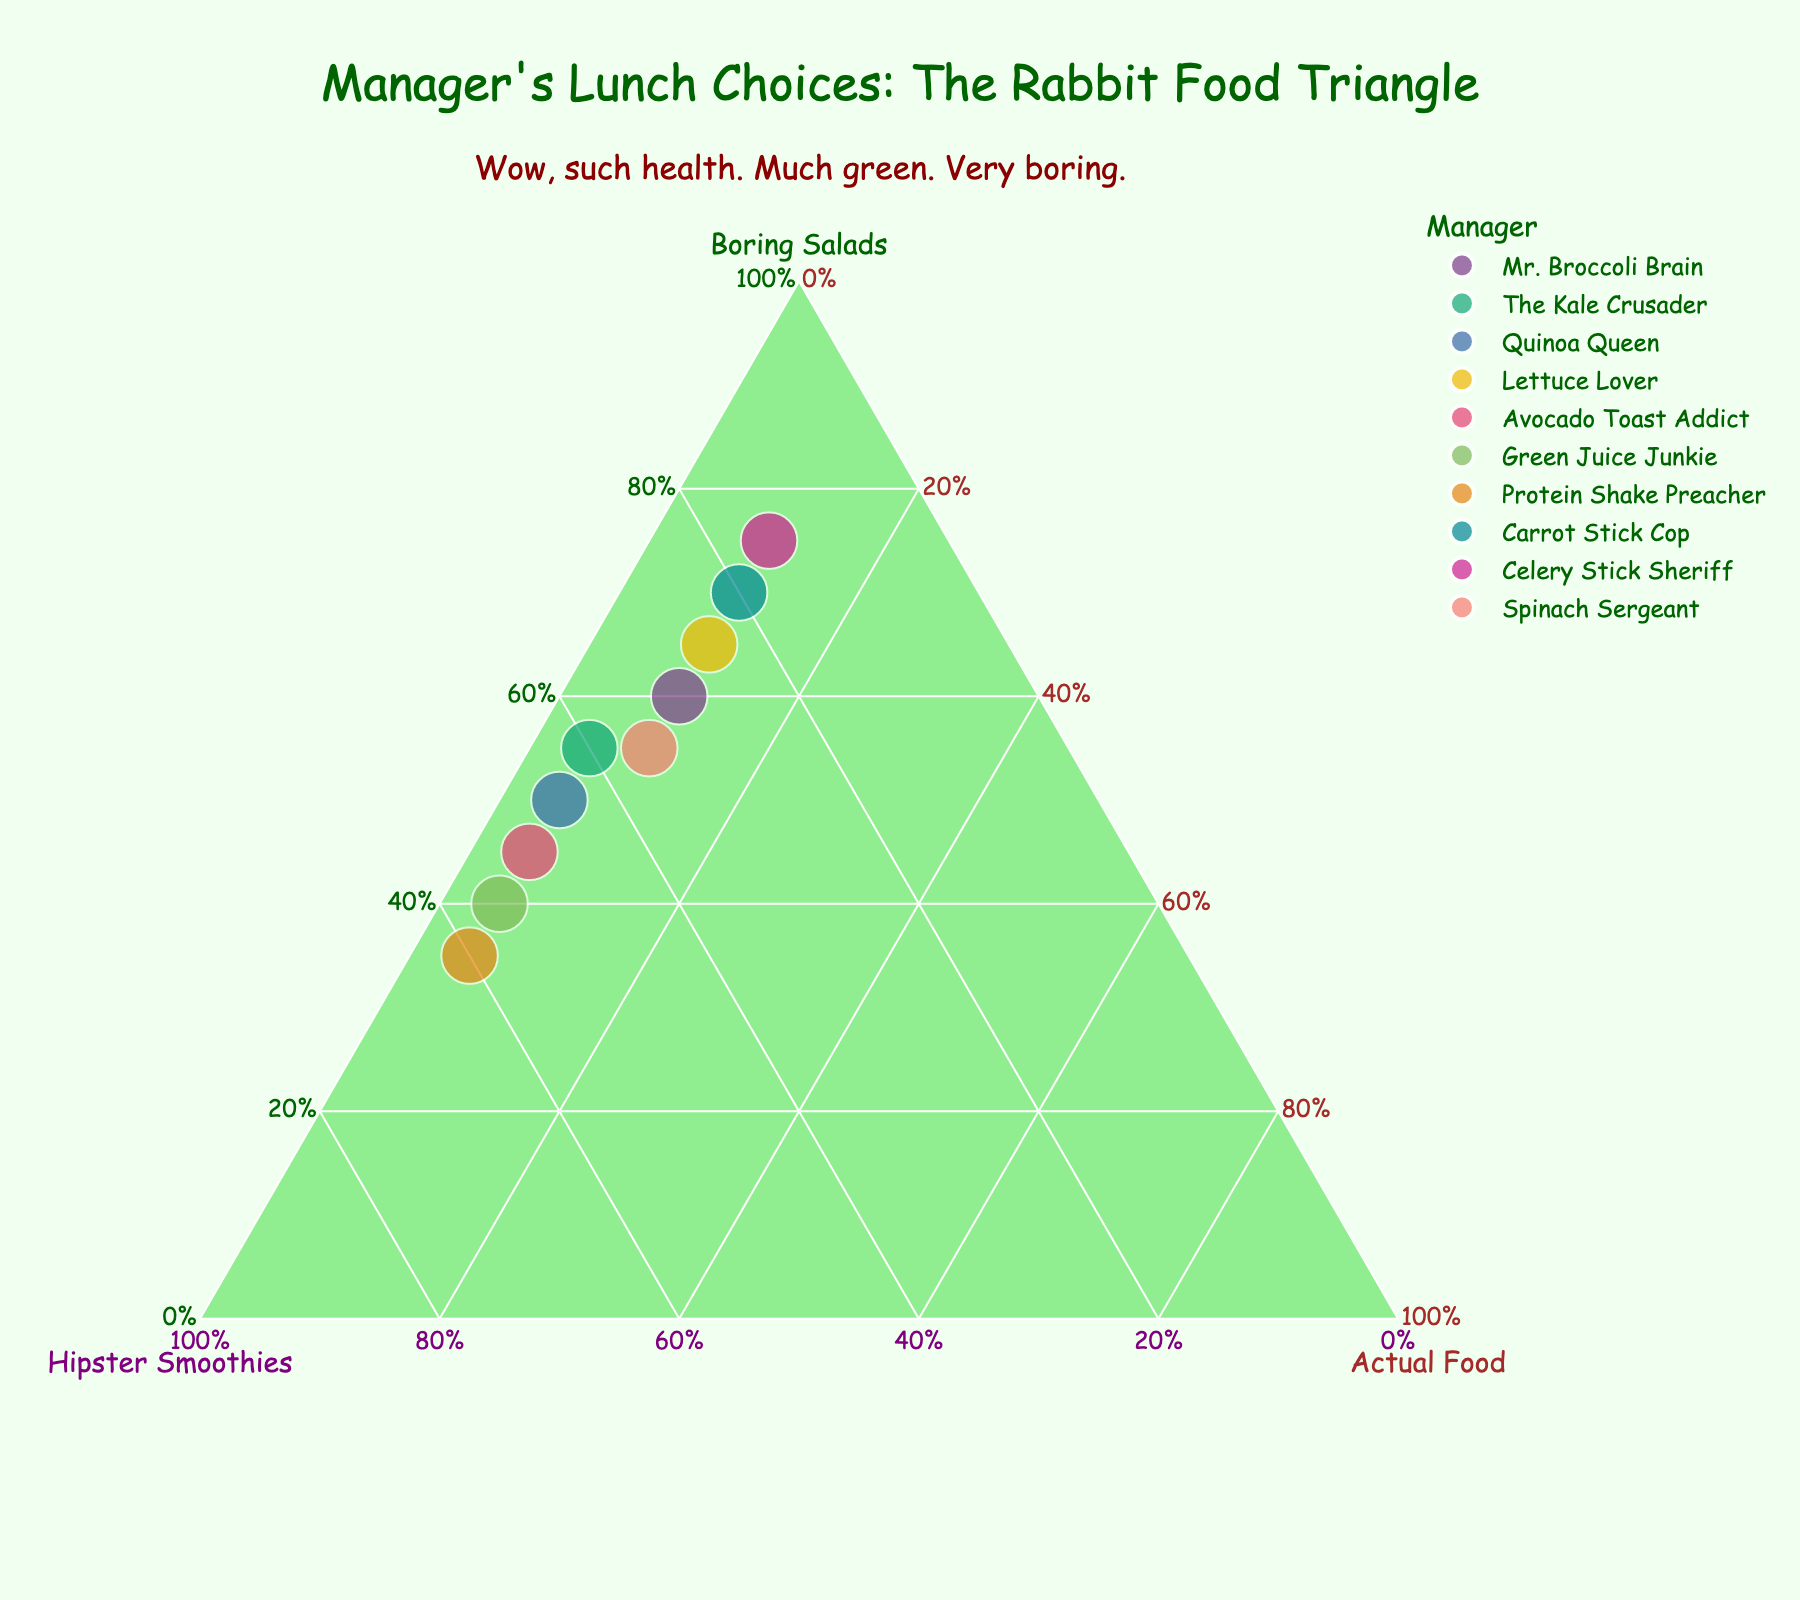Which manager has the highest percentage of salads in their lunch choices? By looking at the point closest to the "Boring Salads" vertex, we see that "Celery Stick Sheriff" is the closest, indicating the highest percentage of salads.
Answer: Celery Stick Sheriff What's the title of the plot? The title is displayed at the top center of the plot and reads "Manager's Lunch Choices: The Rabbit Food Triangle."
Answer: Manager's Lunch Choices: The Rabbit Food Triangle Which manager has the lowest percentage of cheat meals? The manager closest to the "Hipster Smoothies" vertex, which indicates the lowest percentage of cheat meals, is "The Kale Crusader," "Quinoa Queen," "Avocado Toast Addict," "Green Juice Junkie," and "Protein Shake Preacher," all at the same level.
Answer: The Kale Crusader, Quinoa Queen, Avocado Toast Addict, Green Juice Junkie, Protein Shake Preacher Which axis is titled "Actual Food"? The axis corresponding to "Cheat Meals" is titled "Actual Food," which is shown in brown.
Answer: Cheat Meals axis What are the names of the managers who have an equal percentage of cheat meals? By inspecting the plot, we see that "Mr. Broccoli Brain," "Lettuce Lover," "Carrot Stick Cop," "Celery Stick Sheriff," and "Spinach Sergeant" all have data points on the same level of the "Cheat Meals" axis.
Answer: Mr. Broccoli Brain, Lettuce Lover, Carrot Stick Cop, Celery Stick Sheriff, Spinach Sergeant Which manager has the most balanced diet among salads, smoothies, and cheat meals? The manager closest to the center of the triangle suggests a balanced diet. "Spinach Sergeant" appears closest to the center, implying a nearly equal proportion of all three choices.
Answer: Spinach Sergeant How does "Green Juice Junkie" compare to "Avocado Toast Addict" in terms of their smoothie consumption? "Green Juice Junkie" has a point closer to the Hipster Smoothies vertex than "Avocado Toast Addict," indicating "Green Juice Junkie" has a higher percentage of smoothies.
Answer: Green Juice Junkie has more smoothies Summarize the annotation on the plot. There is a sarcastic annotation placed near the top of the plot that reads, "Wow, such health. Much green. Very boring."
Answer: Wow, such health. Much green. Very boring 